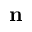<formula> <loc_0><loc_0><loc_500><loc_500>n</formula> 